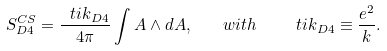<formula> <loc_0><loc_0><loc_500><loc_500>S ^ { C S } _ { D 4 } = \frac { \ t i { k } _ { D 4 } } { 4 \pi } \int A \wedge d A , \quad w i t h \quad \ t i { k } _ { D 4 } \equiv \frac { e ^ { 2 } } { k } .</formula> 